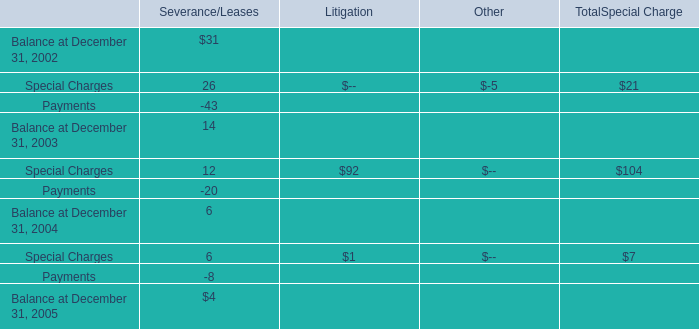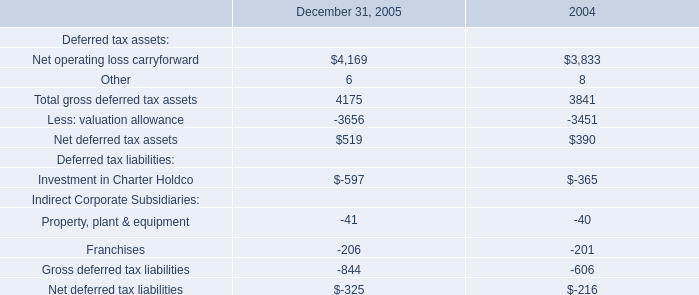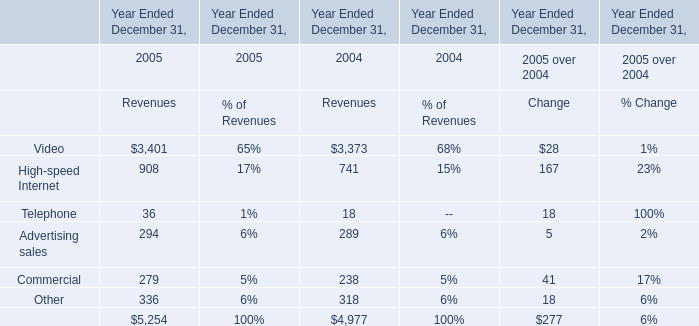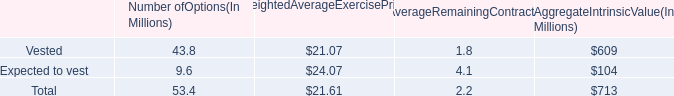Does Video keeps increasing each year between 2005 and2004? 
Answer: Yes. 